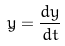Convert formula to latex. <formula><loc_0><loc_0><loc_500><loc_500>\dot { y } = \frac { d y } { d t }</formula> 